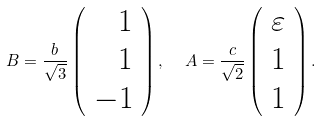Convert formula to latex. <formula><loc_0><loc_0><loc_500><loc_500>B = \frac { b } { \sqrt { 3 } } \left ( \begin{array} { r } 1 \\ 1 \\ - 1 \end{array} \right ) , \ \ A = \frac { c } { \sqrt { 2 } } \left ( \begin{array} { r } \varepsilon \\ 1 \\ 1 \end{array} \right ) .</formula> 